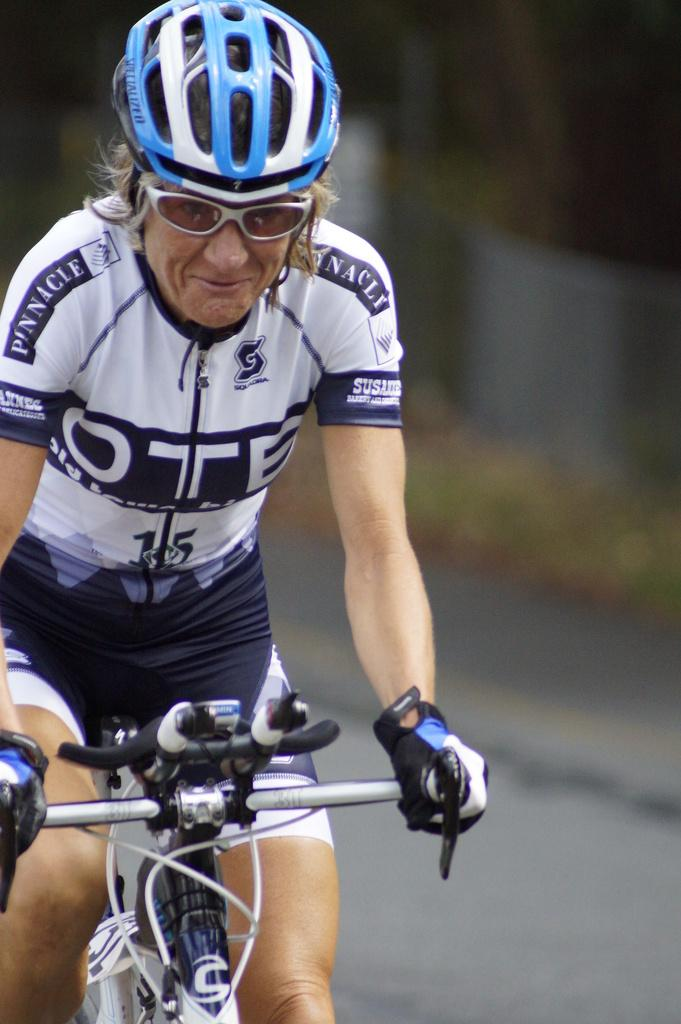What is the main subject of the image? There is a person in the image. What is the person doing in the image? The person is sitting on a bicycle. What safety equipment is the person wearing? The person is wearing a helmet. What accessories is the person wearing? The person is wearing glasses and hand gloves. What type of clothing is the person wearing? The person is wearing clothes. Can you describe the background of the image? The background of the image is blurred. What type of glass is the person drinking from in the image? There is no glass or any indication of drinking in the image; the person is sitting on a bicycle and wearing a helmet, glasses, and hand gloves. 